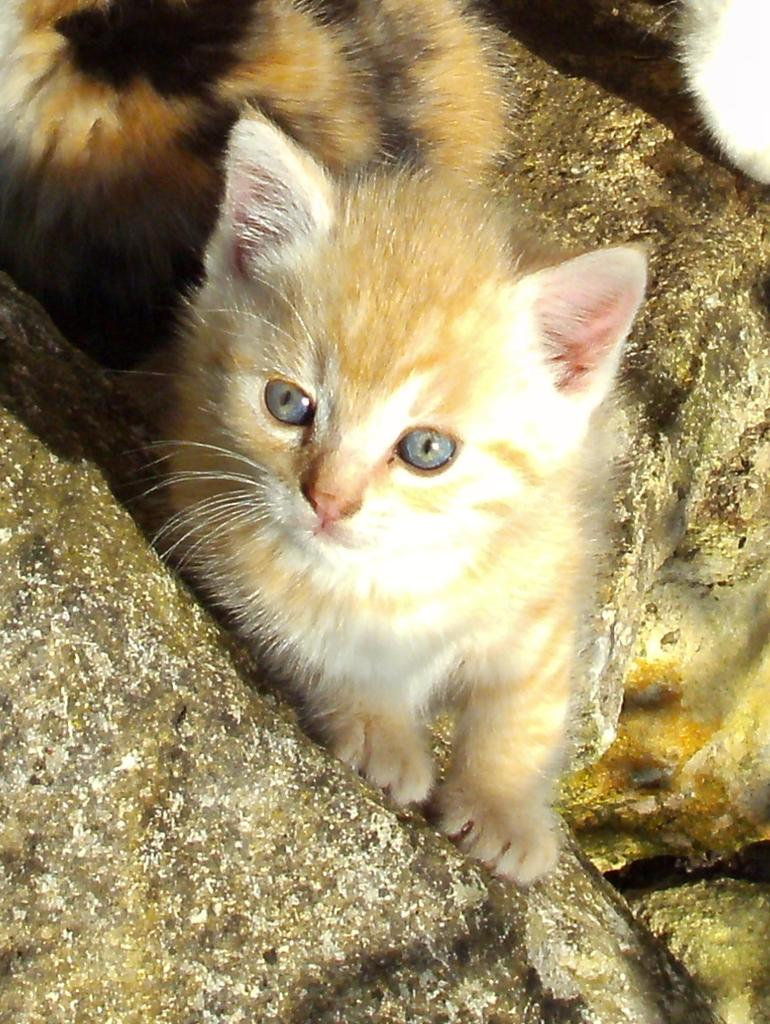What type of animals are present in the image? There are cats in the picture. What can be seen at the bottom of the image? There are stones at the bottom of the image. What type of breakfast is being served to the group of bears in the image? There are no bears or breakfast present in the image; it features cats and stones. 